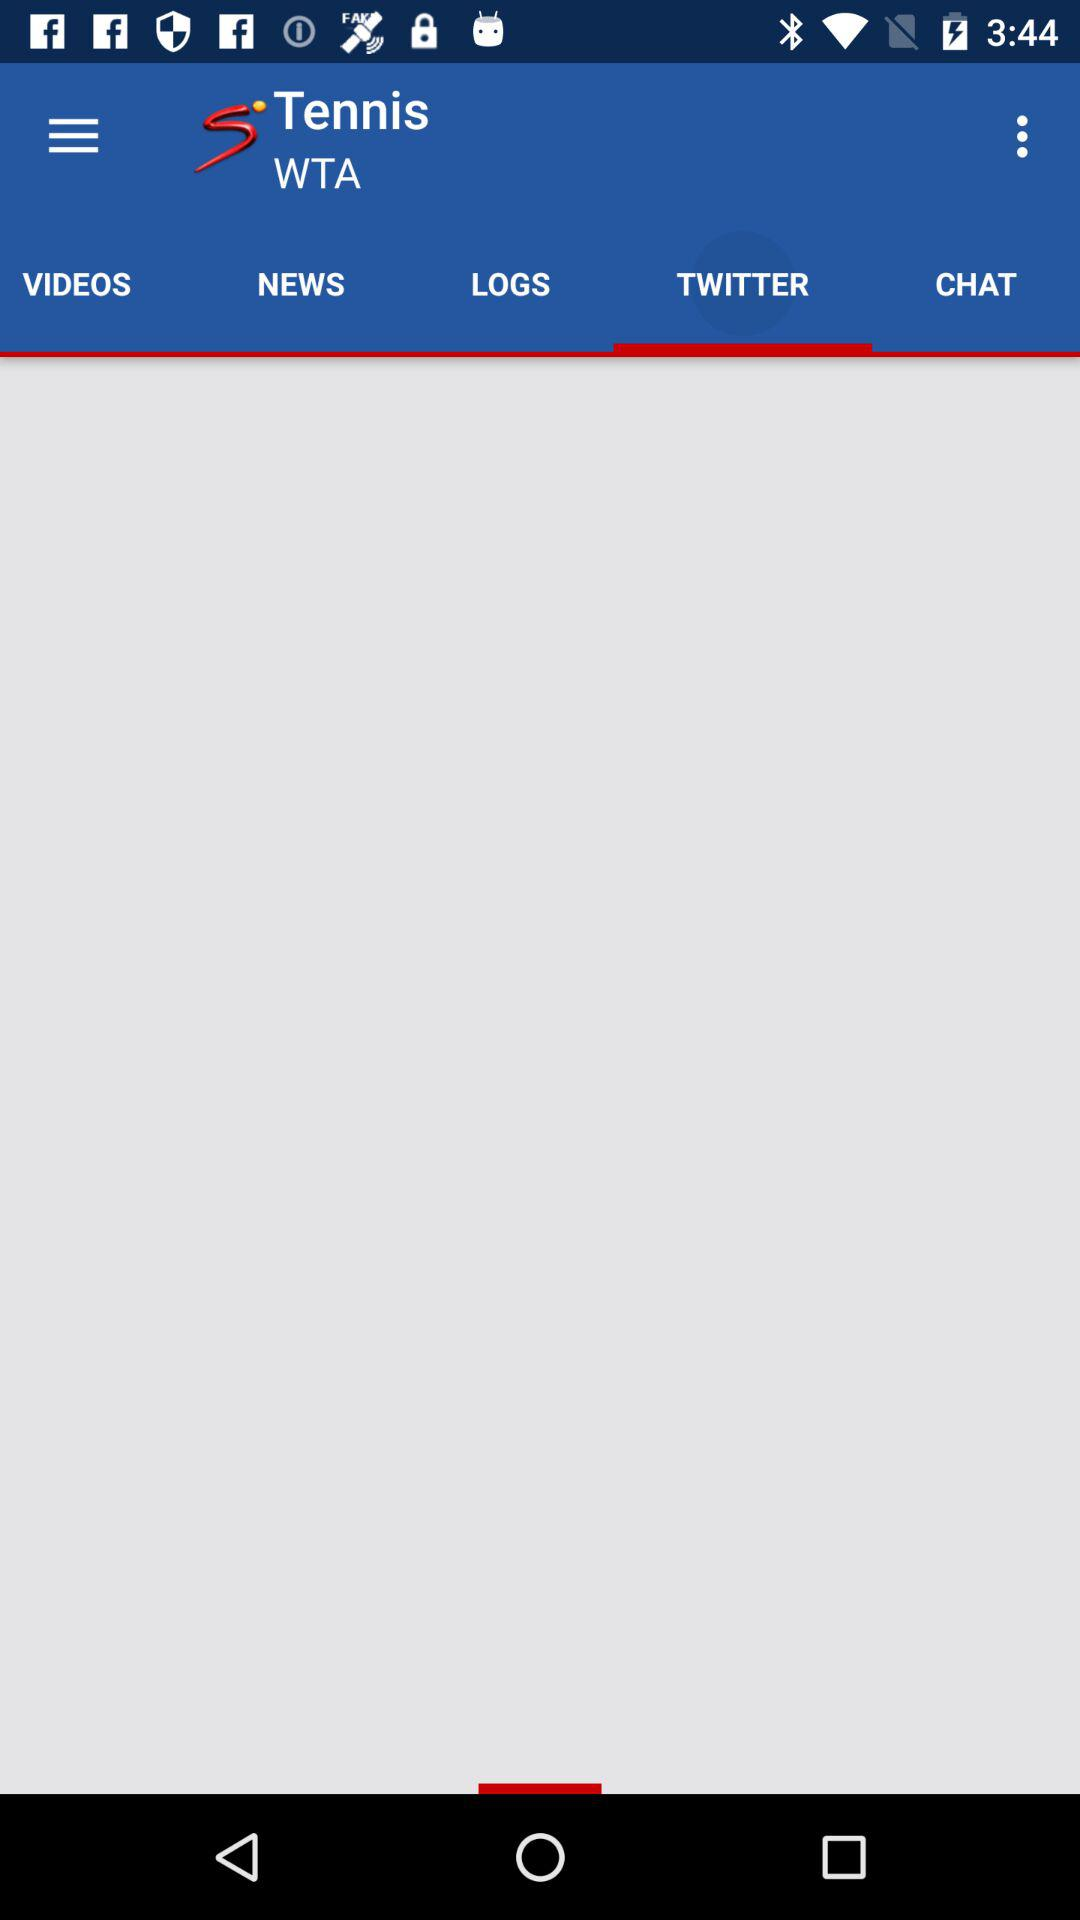Which tab has been selected? The tab "TWITTER" has been selected. 